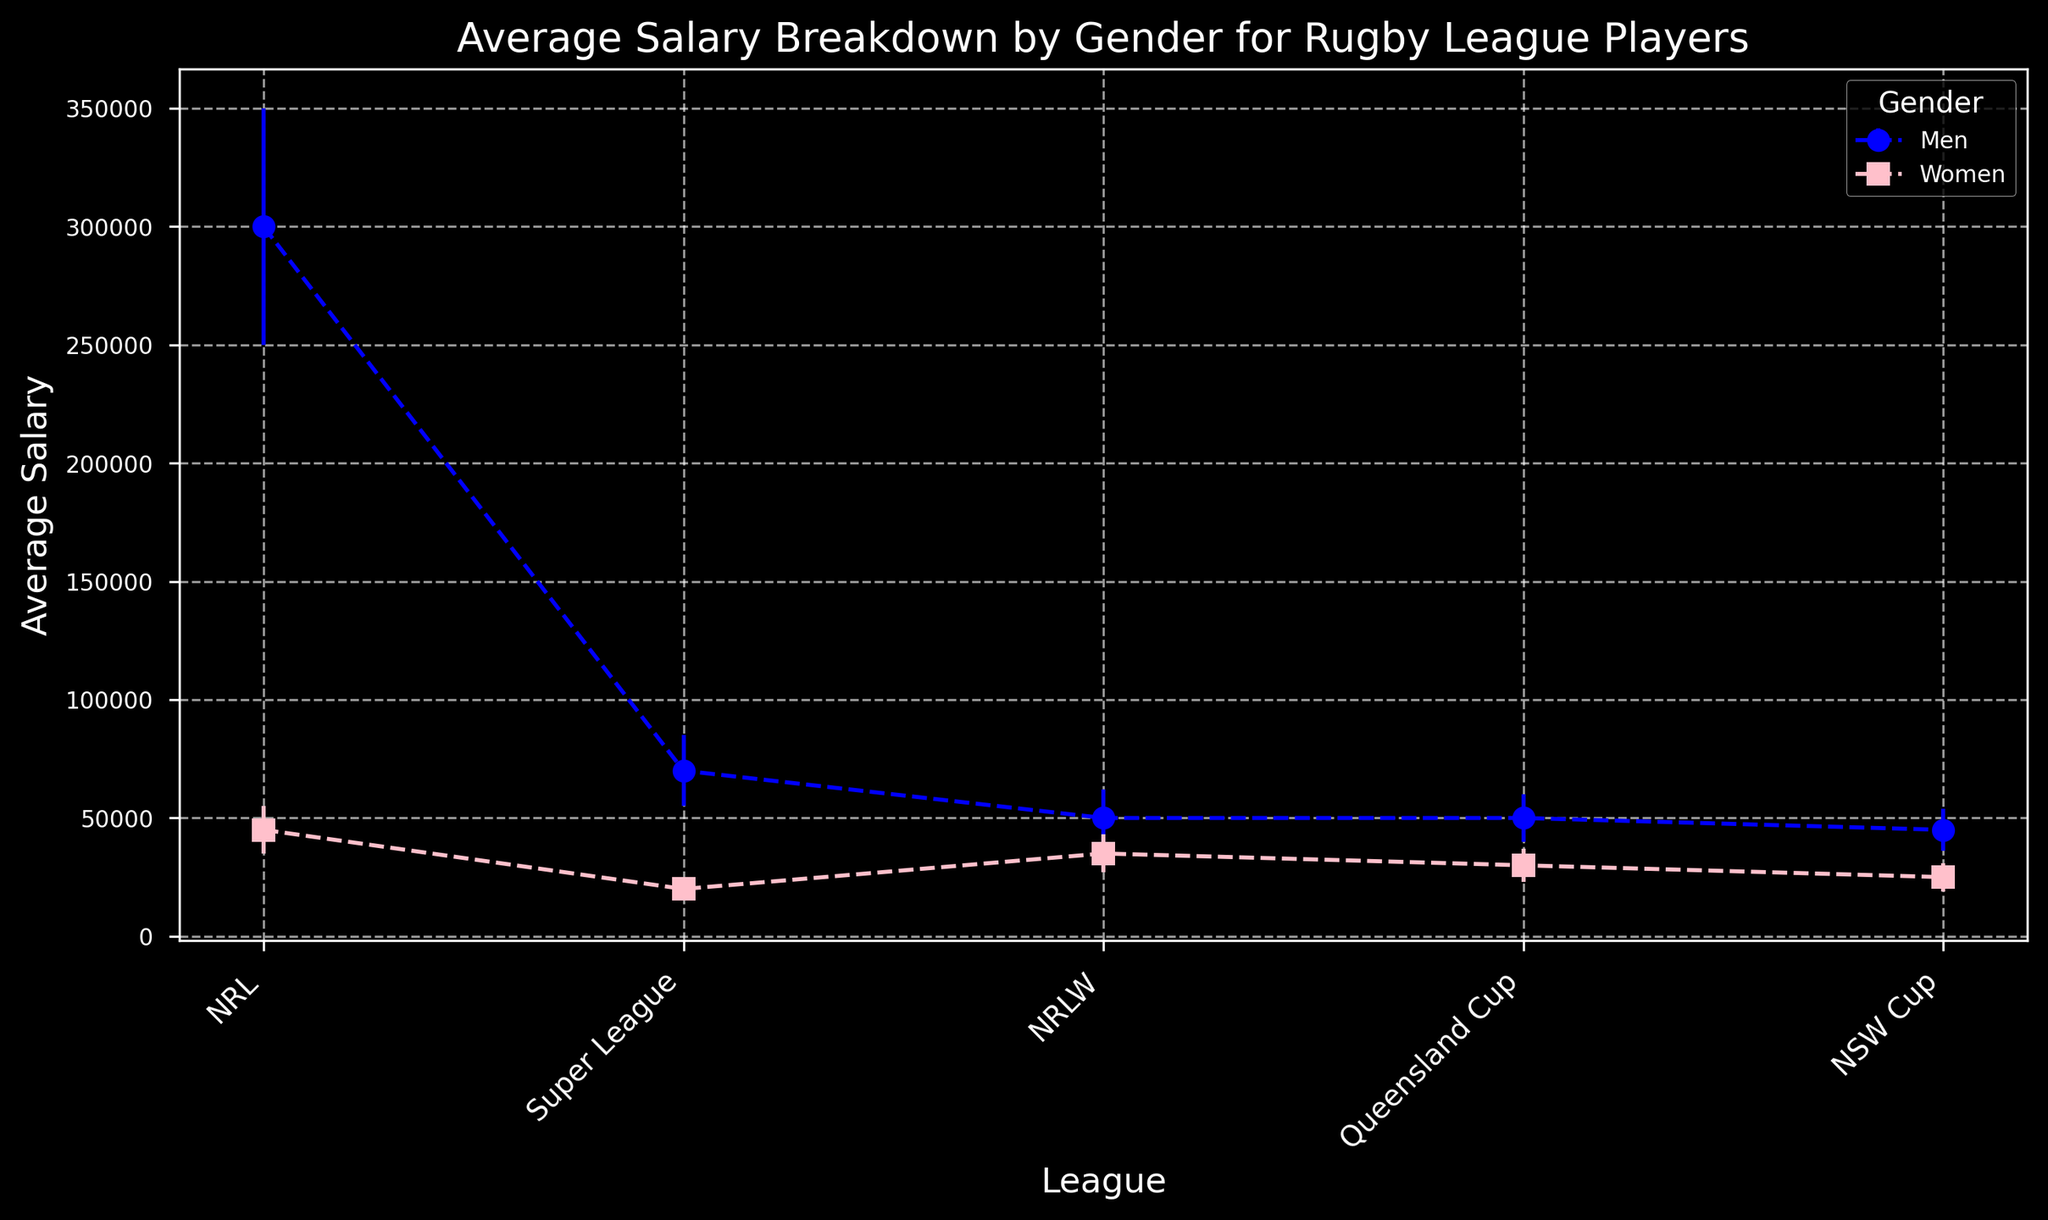Which league has the highest average salary for men? In the chart, looking at the data points for men (marked with 'o' and blue), the NRL league shows the highest average salary.
Answer: NRL Which league has the smallest difference in average salaries between men and women? To determine the smallest difference, we compare average salaries between men and women across all leagues. For the NRLW league, the difference is 15000 (50000 - 35000), which is the smallest compared to other leagues.
Answer: NRLW What is the average salary of women in the Super League? Look at the data points for women (marked with 's' and pink) in the Super League. The average salary is shown as 20000.
Answer: 20000 Compare the average salary of men in the Queensland Cup with women in the same league. In the chart for Queensland Cup, men have an average salary of 50000 whereas women have 30000.
Answer: Men have a higher average salary Which gender and league combination has the highest standard deviation in average salary? On the chart, the error bars represent the standard deviation. The largest error bar is from NRL men, having the highest standard deviation of 50000.
Answer: NRL men Is the average salary for women in the NRL more than the average salary for men in the NSW Cup? In the chart, the average salary for women in the NRL is 45000. The average salary for men in the NSW Cup is 45000. Both values are equal.
Answer: Equal What is the total average salary for men across all leagues combined? Adding the average salaries for men across all leagues: 300000 (NRL) + 70000 (Super League) + 50000 (NRLW) + 50000 (Queensland Cup) + 45000 (NSW Cup) equals 515000.
Answer: 515000 How much higher is the average salary of men in the NRL compared to women in the Queensland Cup? The average salary for men in the NRL is 300000, and for women in the Queensland Cup is 30000. The difference is 300000 - 30000 which equals 270000.
Answer: 270000 In which league do women have the lowest average salary? Observing the average salaries for women across all leagues, the lowest salary is for women in the Super League with 20000.
Answer: Super League Identify the league with the smallest standard deviation for women’s average salary. From the error bars representing standard deviation for women, the smallest one is in the Super League, showing a standard deviation of 5000.
Answer: Super League 